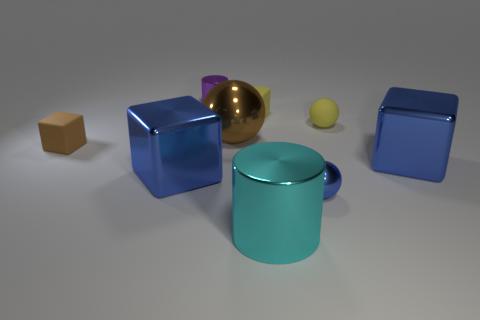Can you describe the lighting in the scene and how it might affect the appearance of the objects? The scene is softly lit with what appears to be a diffused overhead light source, which creates gentle shadows and highlights on the objects. This sort of lighting minimizes harsh shadows and allows the colors and textures of the objects to be perceived clearly, albeit the reflective surfaces may catch light differently, altering the color perception slightly.  Are there any reflections or textures on the objects that reveal more about the light source? Yes, the reflective surfaces, particularly on the metallic sphere and the glossy cubes, show highlights and soft reflections. These reflections indicate a broad light source above the scene, given the way light scatters across their surfaces. There are no sharp or concentrated reflections, which aligns with the use of a diffused light likely intended to mimic natural lighting. 